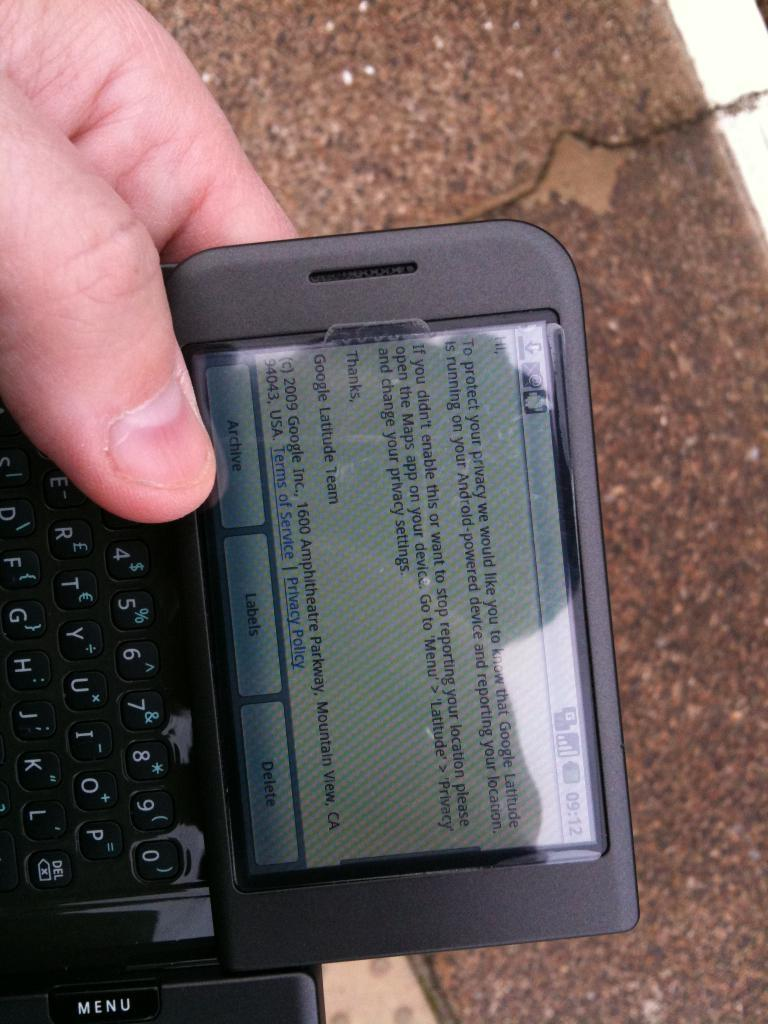Provide a one-sentence caption for the provided image. a black slider phone that says 09:12 as the time. 